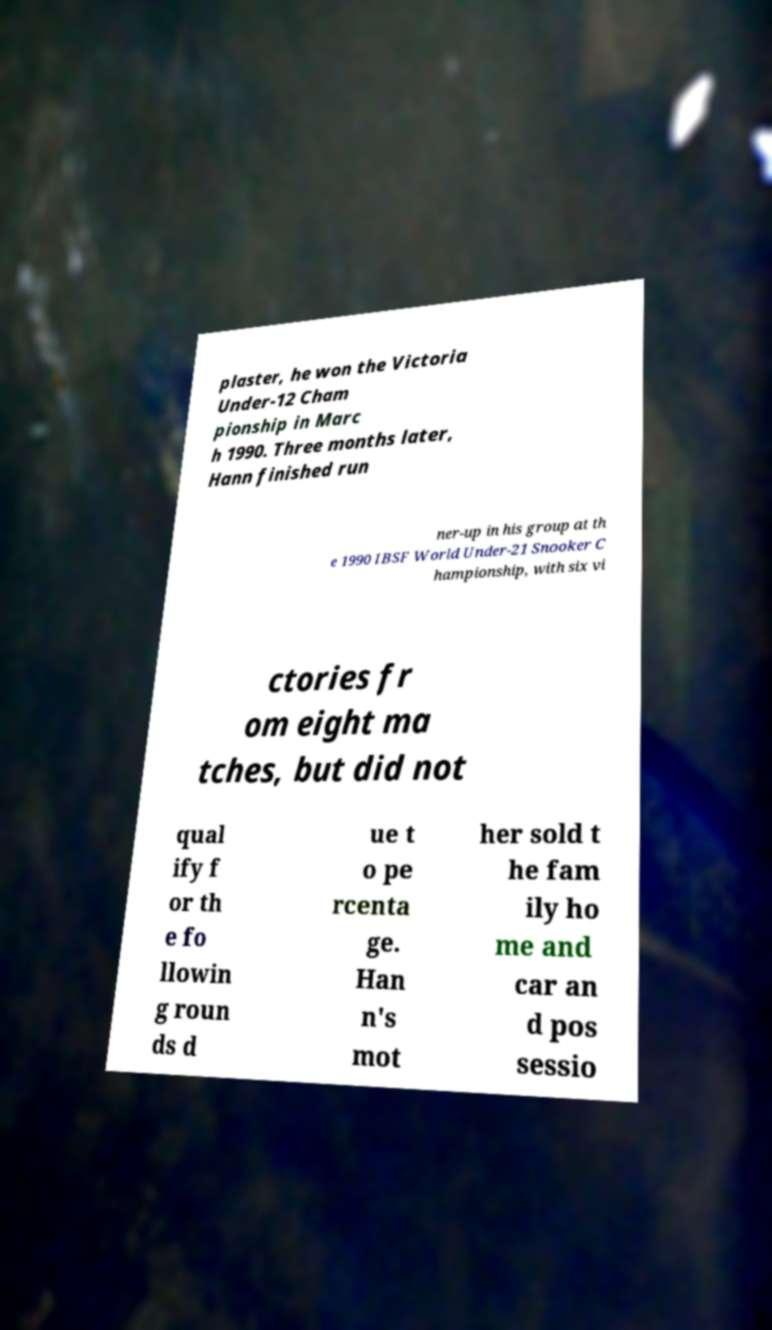I need the written content from this picture converted into text. Can you do that? plaster, he won the Victoria Under-12 Cham pionship in Marc h 1990. Three months later, Hann finished run ner-up in his group at th e 1990 IBSF World Under-21 Snooker C hampionship, with six vi ctories fr om eight ma tches, but did not qual ify f or th e fo llowin g roun ds d ue t o pe rcenta ge. Han n's mot her sold t he fam ily ho me and car an d pos sessio 